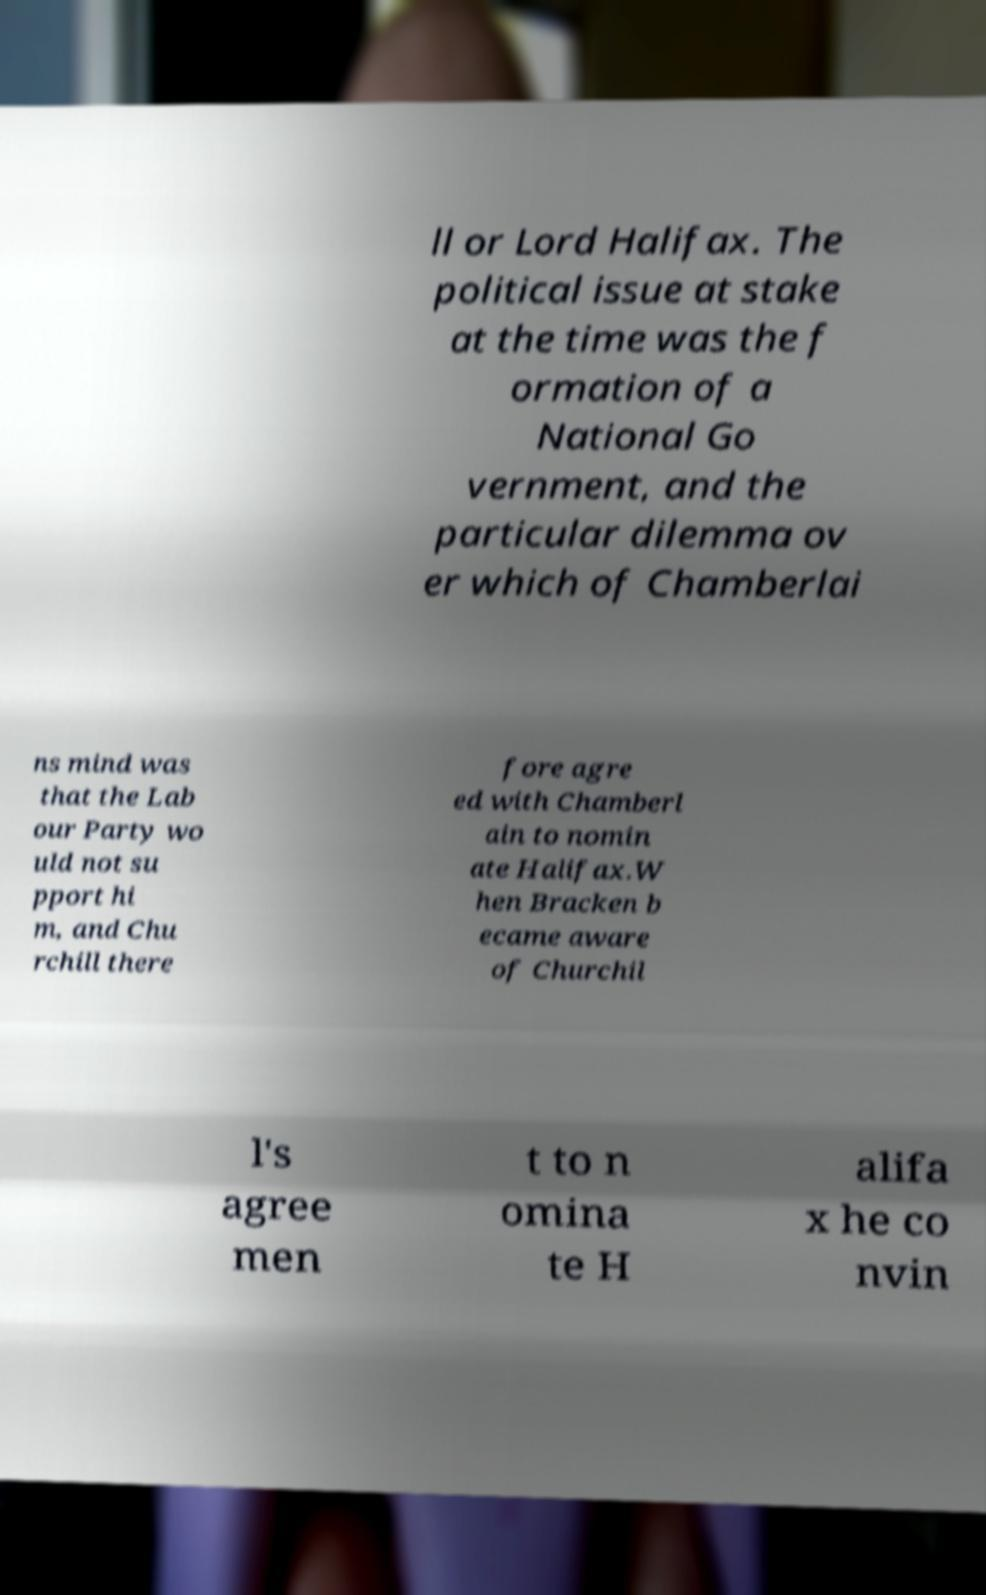Can you read and provide the text displayed in the image?This photo seems to have some interesting text. Can you extract and type it out for me? ll or Lord Halifax. The political issue at stake at the time was the f ormation of a National Go vernment, and the particular dilemma ov er which of Chamberlai ns mind was that the Lab our Party wo uld not su pport hi m, and Chu rchill there fore agre ed with Chamberl ain to nomin ate Halifax.W hen Bracken b ecame aware of Churchil l's agree men t to n omina te H alifa x he co nvin 